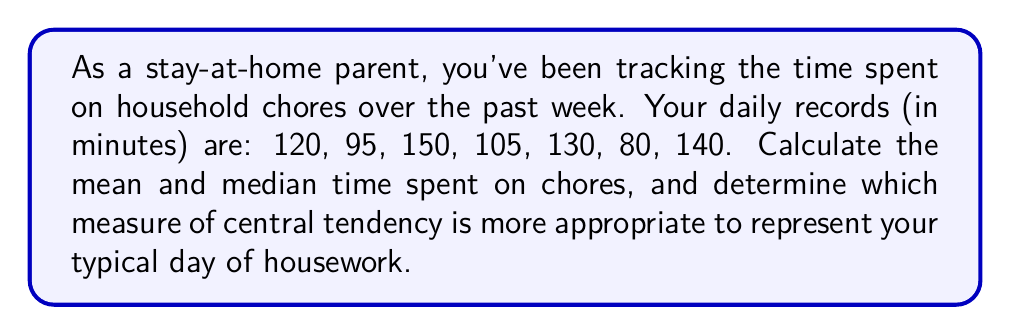Provide a solution to this math problem. 1. To calculate the mean:
   a. Sum all values: $120 + 95 + 150 + 105 + 130 + 80 + 140 = 820$
   b. Divide by the number of days (7):
      $$\text{Mean} = \frac{820}{7} \approx 117.14 \text{ minutes}$$

2. To calculate the median:
   a. Order the values: 80, 95, 105, 120, 130, 140, 150
   b. Find the middle value (4th in this case):
      $$\text{Median} = 120 \text{ minutes}$$

3. Comparing mean and median:
   The mean (117.14 minutes) is slightly lower than the median (120 minutes).
   The difference is small, indicating a relatively symmetric distribution.

4. Choosing the appropriate measure:
   Both measures are close, suggesting either could be used. However, the median might be slightly more appropriate because:
   a. It's less affected by extreme values (80 and 150 minutes).
   b. It represents the middle value, which could be more representative of a "typical" day.
   c. As a parent, your daily chores might vary, and the median captures the middle ground better.
Answer: Mean: 117.14 minutes, Median: 120 minutes. Median is slightly more appropriate. 